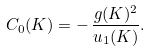Convert formula to latex. <formula><loc_0><loc_0><loc_500><loc_500>C _ { 0 } ( K ) = - \, \frac { g ( K ) ^ { 2 } } { u _ { 1 } ( K ) } .</formula> 